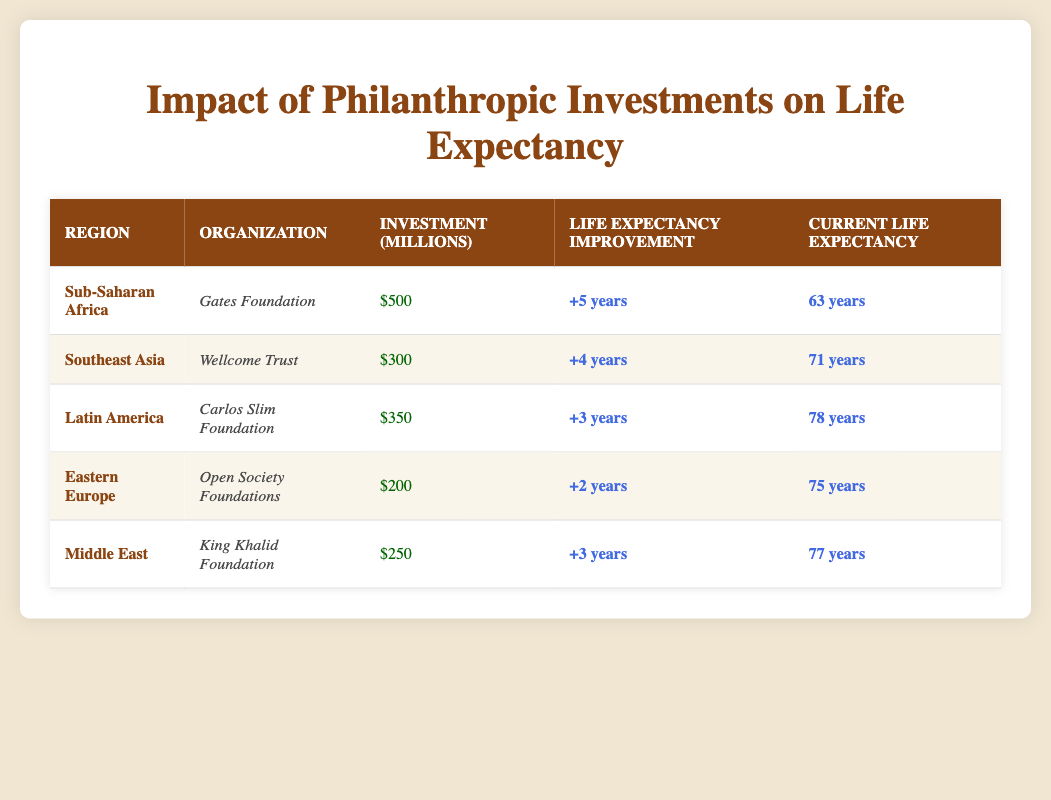What is the current life expectancy in Sub-Saharan Africa? According to the table, the current life expectancy in Sub-Saharan Africa is listed as 63 years.
Answer: 63 years Which organization has invested the most in health care initiatives? The Gates Foundation has invested 500 million, which is the highest amount compared to other organizations listed in the table.
Answer: Gates Foundation What is the total life expectancy improvement from healthcare initiatives in Latin America and Eastern Europe combined? Latin America's improvement is 3 years and Eastern Europe's is 2 years. Adding these gives 3 + 2 = 5 years of total improvement.
Answer: 5 years Is the life expectancy improvement from the Gates Foundation greater than that of the Wellcome Trust? The Gates Foundation has a life expectancy improvement of 5 years, while the Wellcome Trust has 4 years. Therefore, yes, the improvement from the Gates Foundation is greater.
Answer: Yes What is the average current life expectancy of the regions listed? The current life expectancies are 63, 71, 78, 75, and 77 years. Adding these up gives 364, and dividing by 5 results in an average of 364 / 5 = 72.8 years.
Answer: 72.8 years Which region has the least life expectancy improvement? Eastern Europe has the least life expectancy improvement of just 2 years, compared to other regions which have improvements of 3, 4, or 5 years.
Answer: Eastern Europe Does the King Khalid Foundation's investment result in a lower life expectancy than the Carlos Slim Foundation’s? King Khalid Foundation results in a current life expectancy of 77 years which is higher than Carlos Slim Foundation’s life expectancy of 78 years. Thus, the statement is false.
Answer: No What is the difference in investment amount between the Gates Foundation and the Open Society Foundations? The Gates Foundation invested 500 million while the Open Society Foundations invested 200 million. So, the difference is 500 - 200 = 300 million.
Answer: 300 million 